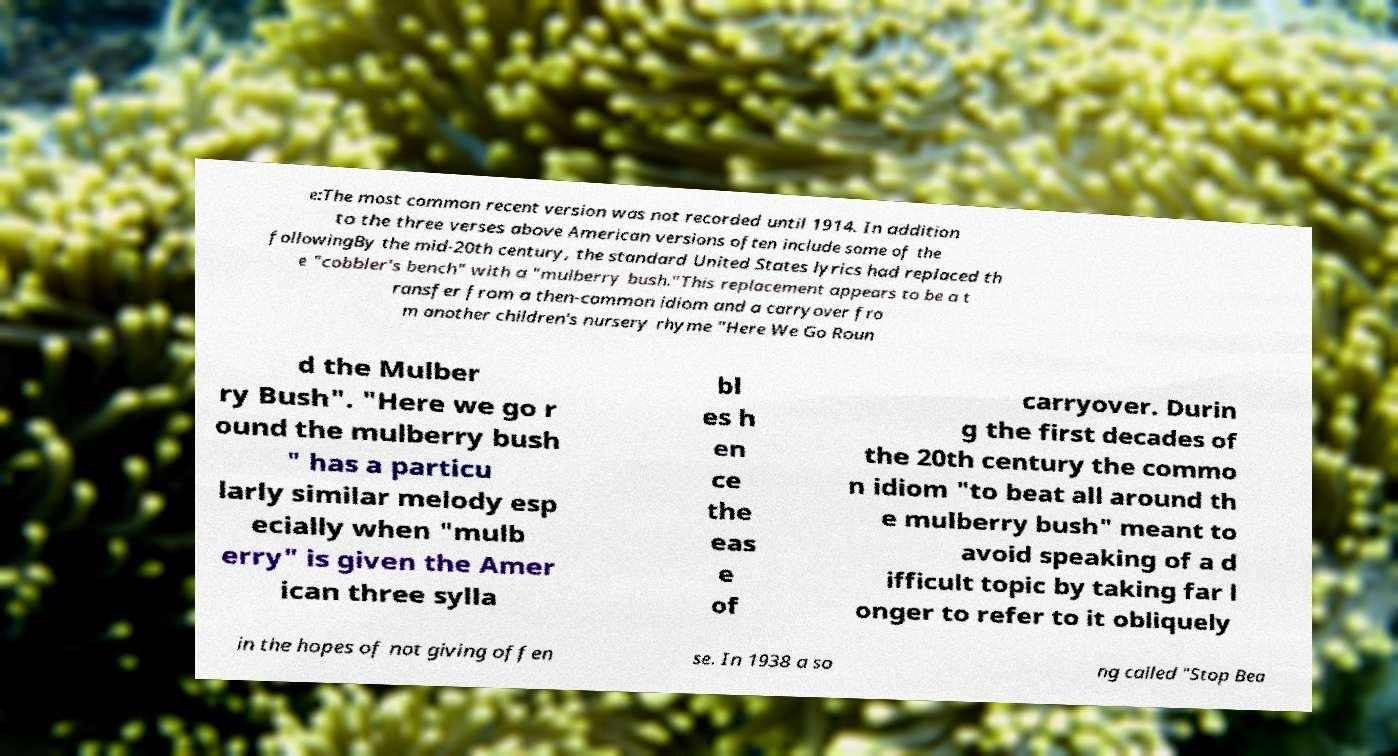Can you accurately transcribe the text from the provided image for me? e:The most common recent version was not recorded until 1914. In addition to the three verses above American versions often include some of the followingBy the mid-20th century, the standard United States lyrics had replaced th e "cobbler's bench" with a "mulberry bush."This replacement appears to be a t ransfer from a then-common idiom and a carryover fro m another children's nursery rhyme "Here We Go Roun d the Mulber ry Bush". "Here we go r ound the mulberry bush " has a particu larly similar melody esp ecially when "mulb erry" is given the Amer ican three sylla bl es h en ce the eas e of carryover. Durin g the first decades of the 20th century the commo n idiom "to beat all around th e mulberry bush" meant to avoid speaking of a d ifficult topic by taking far l onger to refer to it obliquely in the hopes of not giving offen se. In 1938 a so ng called "Stop Bea 